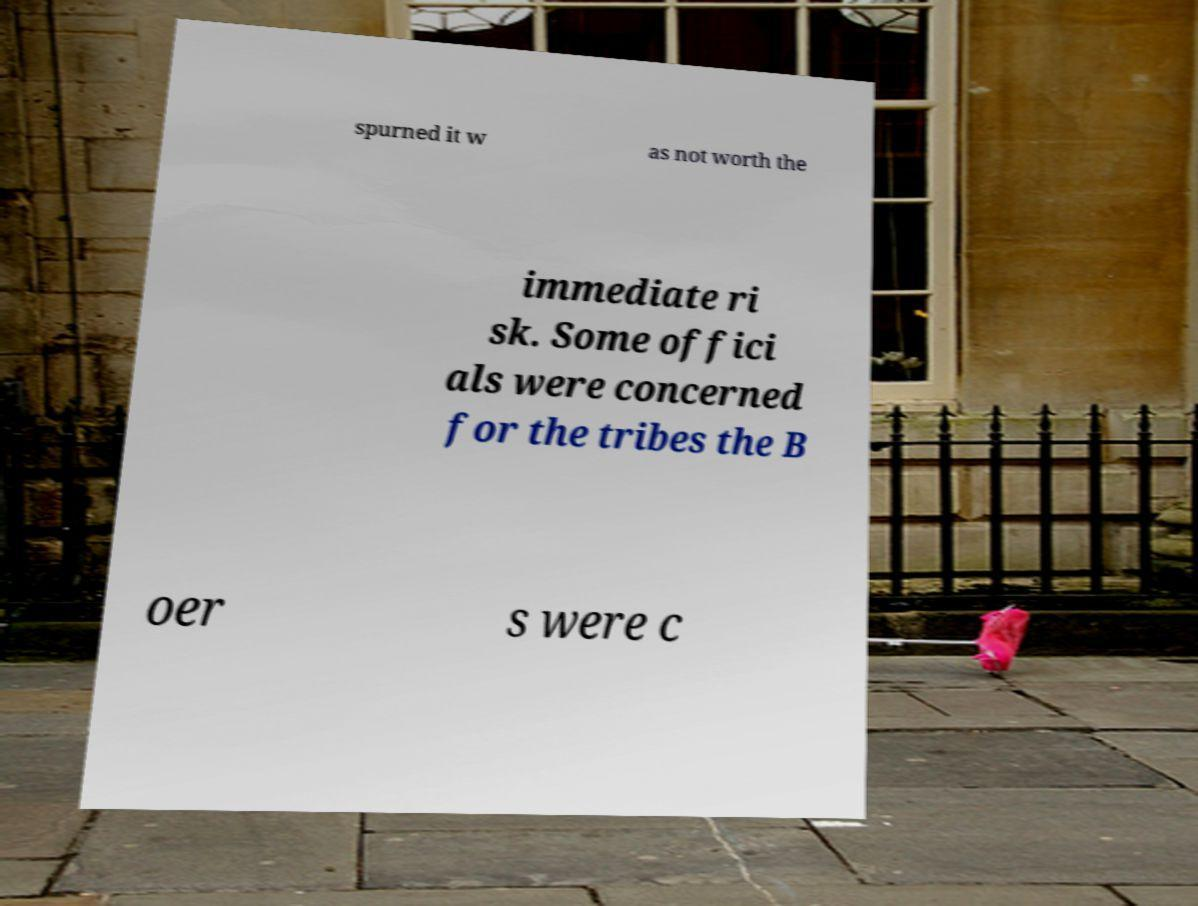There's text embedded in this image that I need extracted. Can you transcribe it verbatim? spurned it w as not worth the immediate ri sk. Some offici als were concerned for the tribes the B oer s were c 